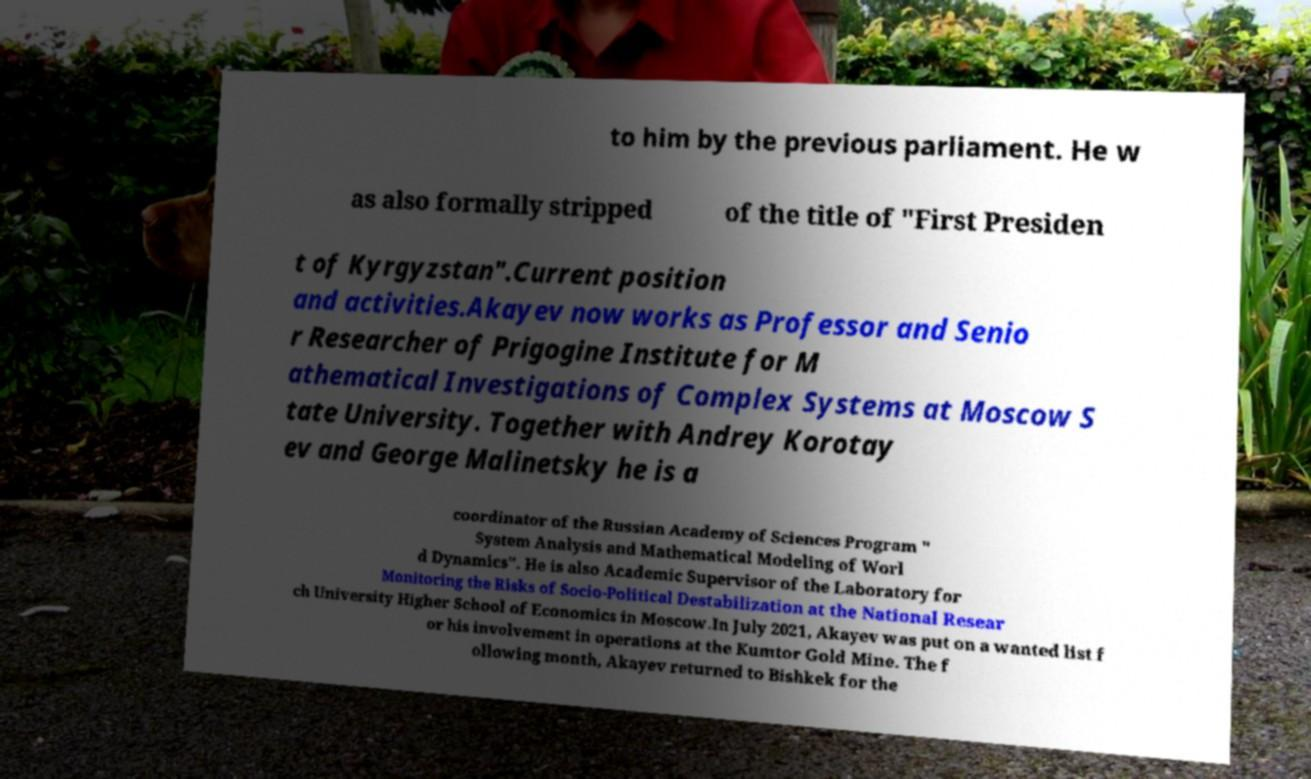Could you extract and type out the text from this image? to him by the previous parliament. He w as also formally stripped of the title of "First Presiden t of Kyrgyzstan".Current position and activities.Akayev now works as Professor and Senio r Researcher of Prigogine Institute for M athematical Investigations of Complex Systems at Moscow S tate University. Together with Andrey Korotay ev and George Malinetsky he is a coordinator of the Russian Academy of Sciences Program " System Analysis and Mathematical Modeling of Worl d Dynamics". He is also Academic Supervisor of the Laboratory for Monitoring the Risks of Socio-Political Destabilization at the National Resear ch University Higher School of Economics in Moscow.In July 2021, Akayev was put on a wanted list f or his involvement in operations at the Kumtor Gold Mine. The f ollowing month, Akayev returned to Bishkek for the 